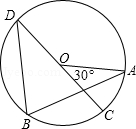How does the principle of the Inscribed Angle Theorem apply to other points on the circle if we choose another diameter? The Inscribed Angle Theorem states that an angle inscribed in a circle is half the measure of the central angle that subtends the same arc. Therefore, if you choose any other diameter in circle O, the angles subtended at any other point on the circle's circumference by this new diameter will also be half of the new central angle. This principle remains consistent regardless of the diameter's position within a perfect circle. 